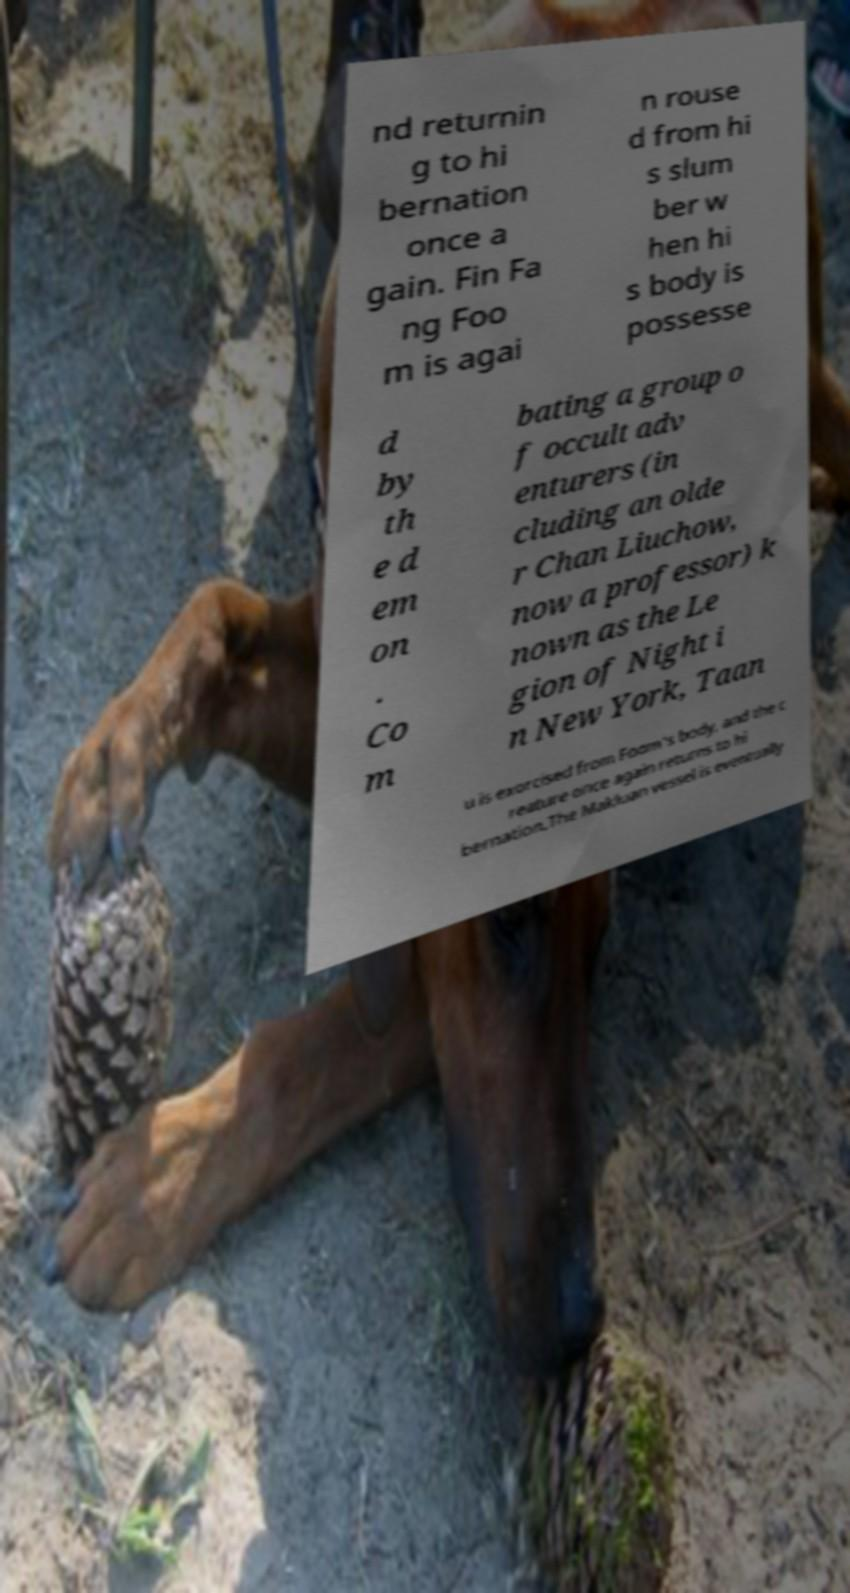I need the written content from this picture converted into text. Can you do that? nd returnin g to hi bernation once a gain. Fin Fa ng Foo m is agai n rouse d from hi s slum ber w hen hi s body is possesse d by th e d em on . Co m bating a group o f occult adv enturers (in cluding an olde r Chan Liuchow, now a professor) k nown as the Le gion of Night i n New York, Taan u is exorcised from Foom's body, and the c reature once again returns to hi bernation.The Makluan vessel is eventually 